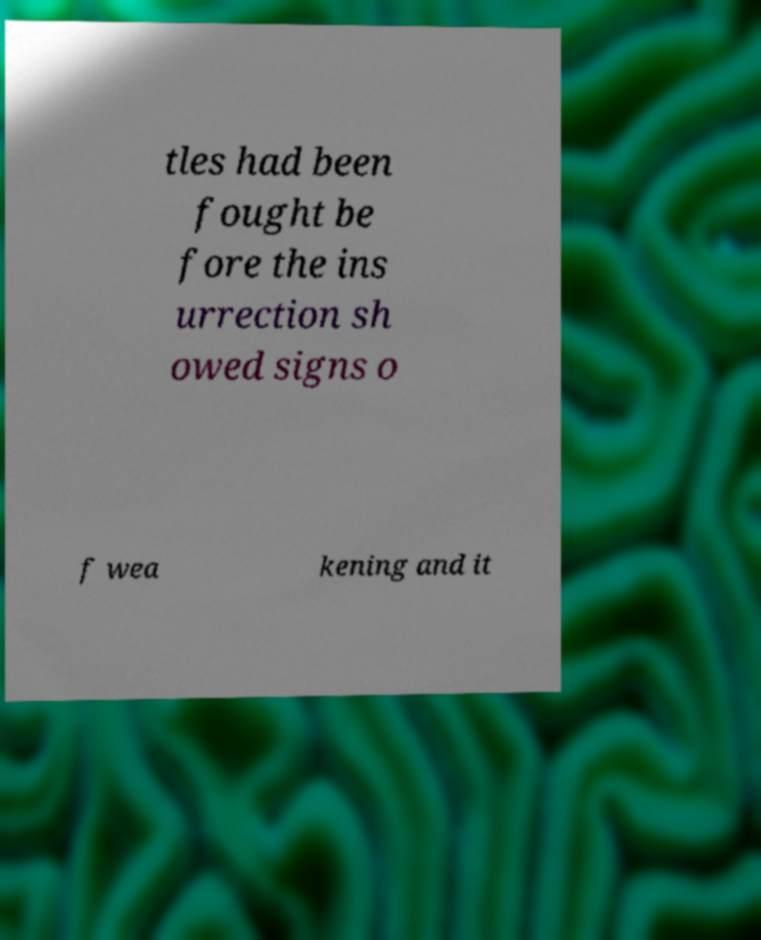What messages or text are displayed in this image? I need them in a readable, typed format. tles had been fought be fore the ins urrection sh owed signs o f wea kening and it 